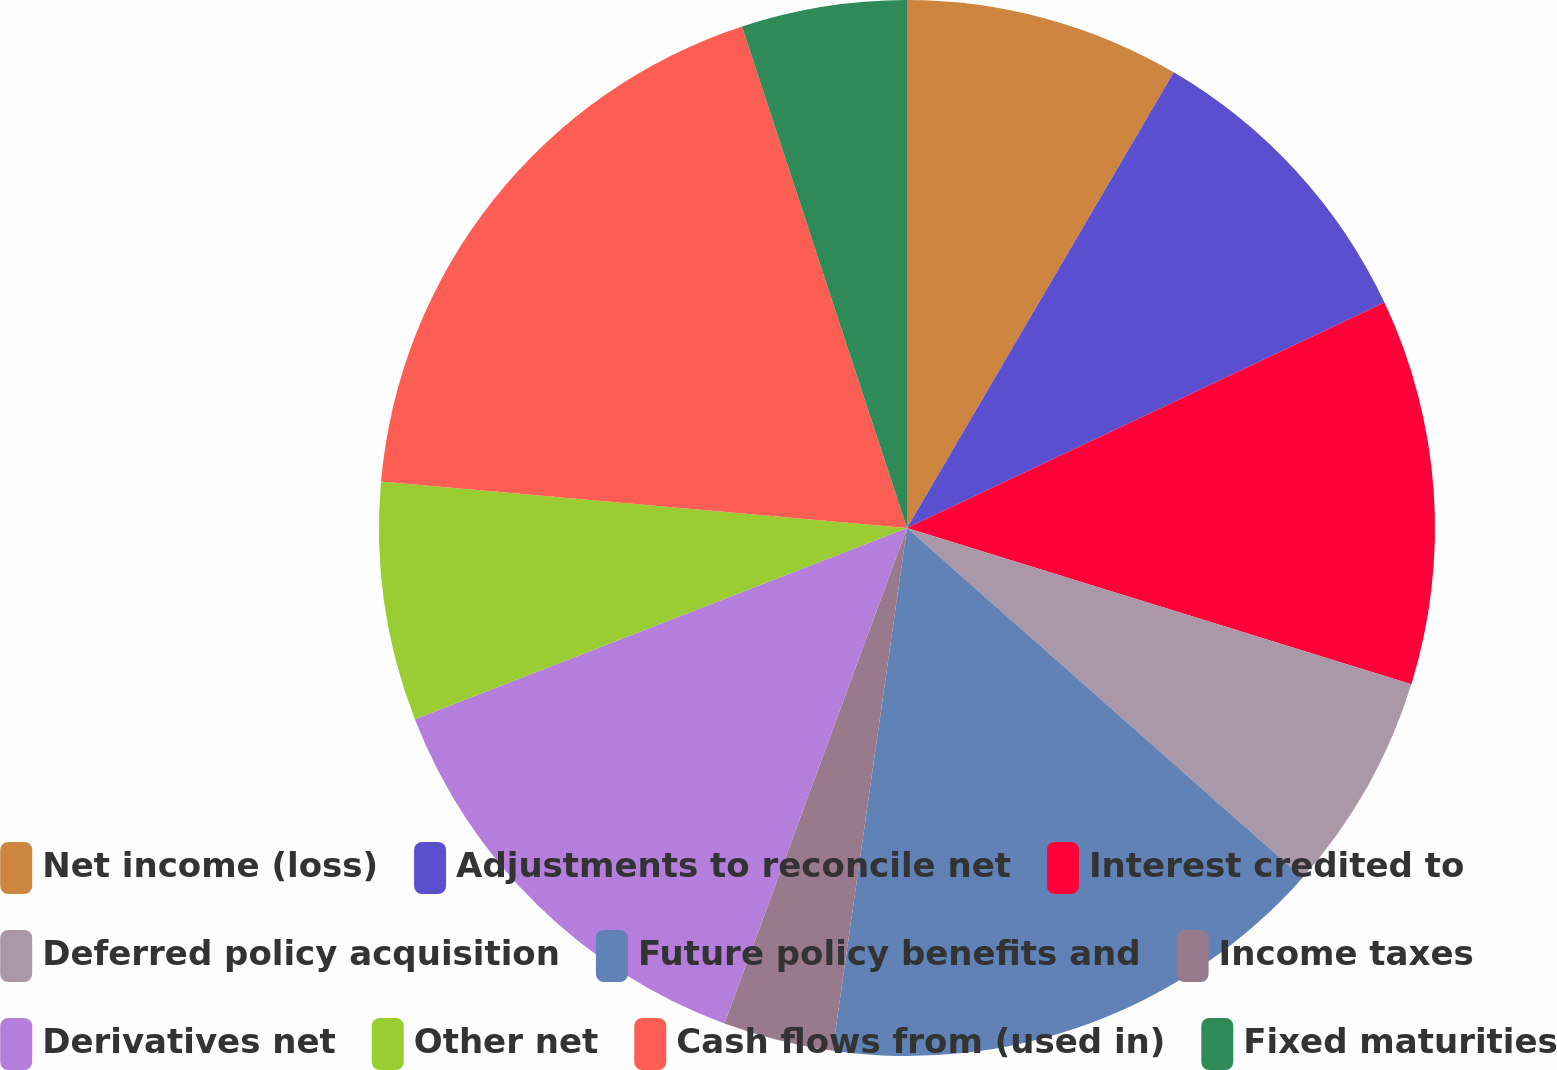<chart> <loc_0><loc_0><loc_500><loc_500><pie_chart><fcel>Net income (loss)<fcel>Adjustments to reconcile net<fcel>Interest credited to<fcel>Deferred policy acquisition<fcel>Future policy benefits and<fcel>Income taxes<fcel>Derivatives net<fcel>Other net<fcel>Cash flows from (used in)<fcel>Fixed maturities<nl><fcel>8.43%<fcel>9.55%<fcel>11.8%<fcel>6.74%<fcel>15.73%<fcel>3.37%<fcel>13.48%<fcel>7.3%<fcel>18.54%<fcel>5.06%<nl></chart> 